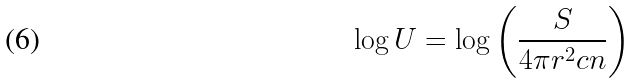Convert formula to latex. <formula><loc_0><loc_0><loc_500><loc_500>\log U = \log \left ( \frac { S } { 4 \pi r ^ { 2 } c n } \right )</formula> 